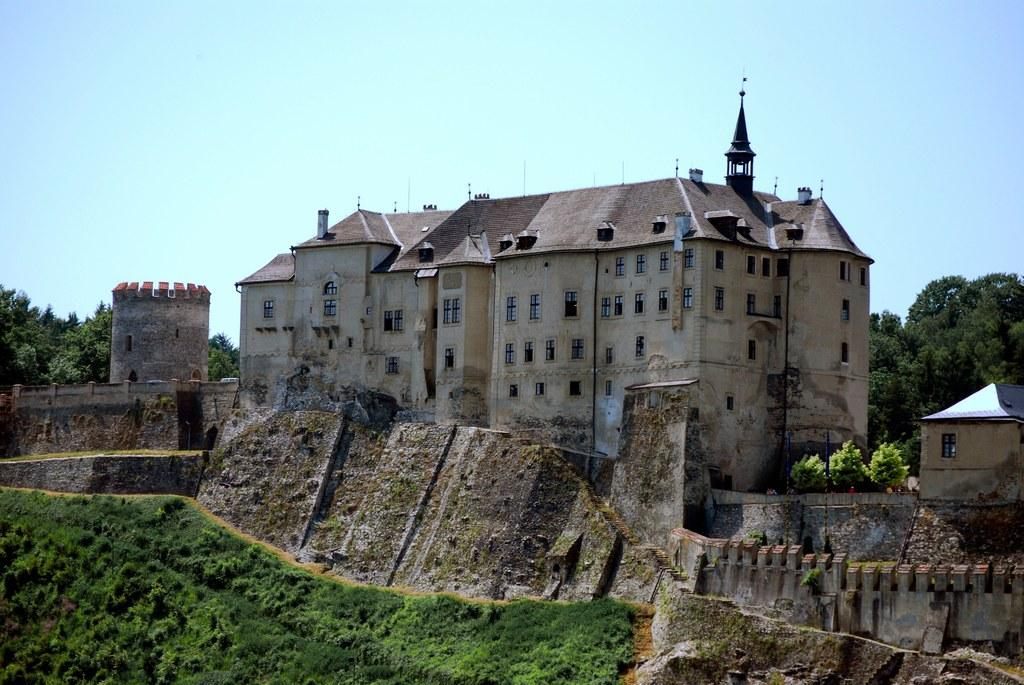What can be seen in the background of the image? There is a sky in the image. What type of structures are present in the image? There are buildings in the image. What architectural feature can be seen on the buildings? There are windows in the image. What type of vegetation is visible in the image? There are trees and grass in the image. Can you describe any other objects present in the image? There are a few other objects in the image. How many pies are being eaten by the mouth in the image? There is no mouth or pies present in the image. 